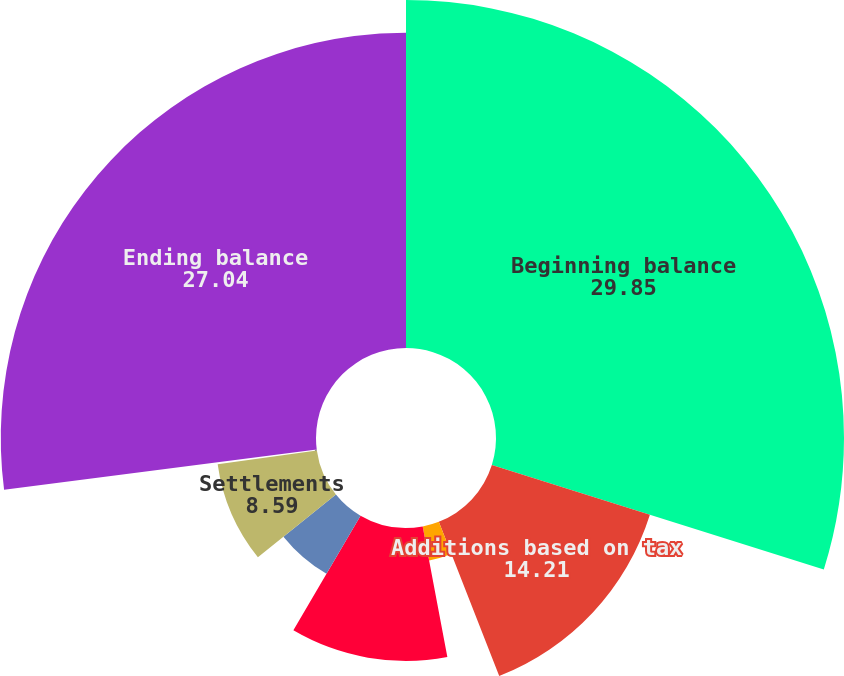Convert chart to OTSL. <chart><loc_0><loc_0><loc_500><loc_500><pie_chart><fcel>Beginning balance<fcel>Additions based on tax<fcel>Additions for tax positions of<fcel>Reductions for tax positions<fcel>Reductions for expiration of<fcel>Settlements<fcel>Change in foreign currency<fcel>Ending balance<nl><fcel>29.85%<fcel>14.21%<fcel>2.97%<fcel>11.4%<fcel>5.78%<fcel>8.59%<fcel>0.16%<fcel>27.04%<nl></chart> 